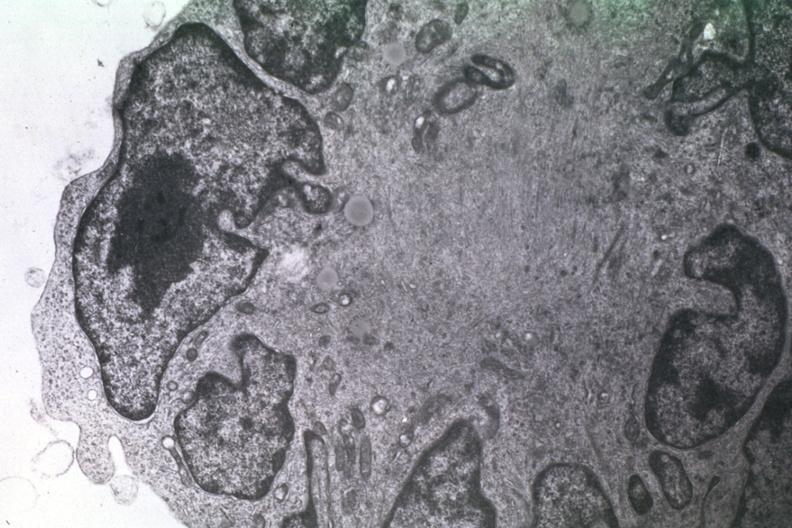does spina bifida show dr garcia tumors 24?
Answer the question using a single word or phrase. No 